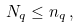<formula> <loc_0><loc_0><loc_500><loc_500>N _ { q } \leq n _ { q } \, ,</formula> 